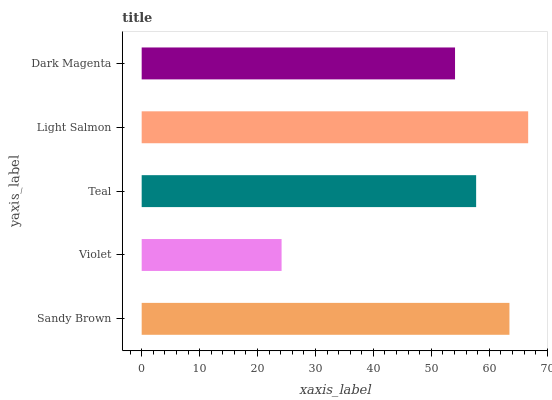Is Violet the minimum?
Answer yes or no. Yes. Is Light Salmon the maximum?
Answer yes or no. Yes. Is Teal the minimum?
Answer yes or no. No. Is Teal the maximum?
Answer yes or no. No. Is Teal greater than Violet?
Answer yes or no. Yes. Is Violet less than Teal?
Answer yes or no. Yes. Is Violet greater than Teal?
Answer yes or no. No. Is Teal less than Violet?
Answer yes or no. No. Is Teal the high median?
Answer yes or no. Yes. Is Teal the low median?
Answer yes or no. Yes. Is Light Salmon the high median?
Answer yes or no. No. Is Light Salmon the low median?
Answer yes or no. No. 